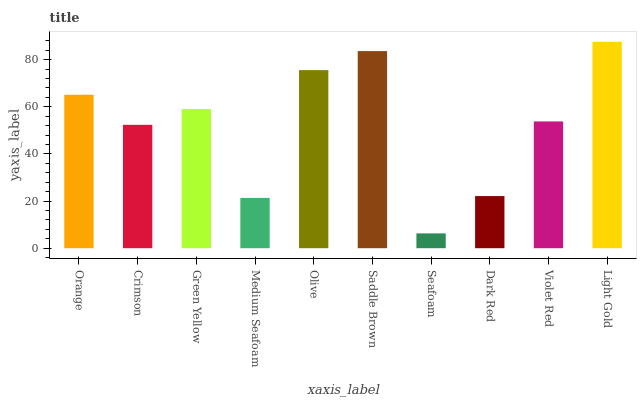Is Seafoam the minimum?
Answer yes or no. Yes. Is Light Gold the maximum?
Answer yes or no. Yes. Is Crimson the minimum?
Answer yes or no. No. Is Crimson the maximum?
Answer yes or no. No. Is Orange greater than Crimson?
Answer yes or no. Yes. Is Crimson less than Orange?
Answer yes or no. Yes. Is Crimson greater than Orange?
Answer yes or no. No. Is Orange less than Crimson?
Answer yes or no. No. Is Green Yellow the high median?
Answer yes or no. Yes. Is Violet Red the low median?
Answer yes or no. Yes. Is Saddle Brown the high median?
Answer yes or no. No. Is Olive the low median?
Answer yes or no. No. 